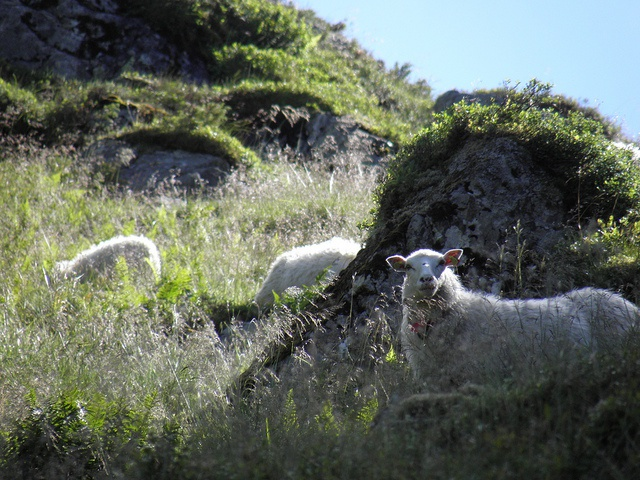Describe the objects in this image and their specific colors. I can see sheep in black, gray, purple, and darkgray tones, sheep in black, gray, white, and darkgray tones, and sheep in black, white, darkgray, and gray tones in this image. 